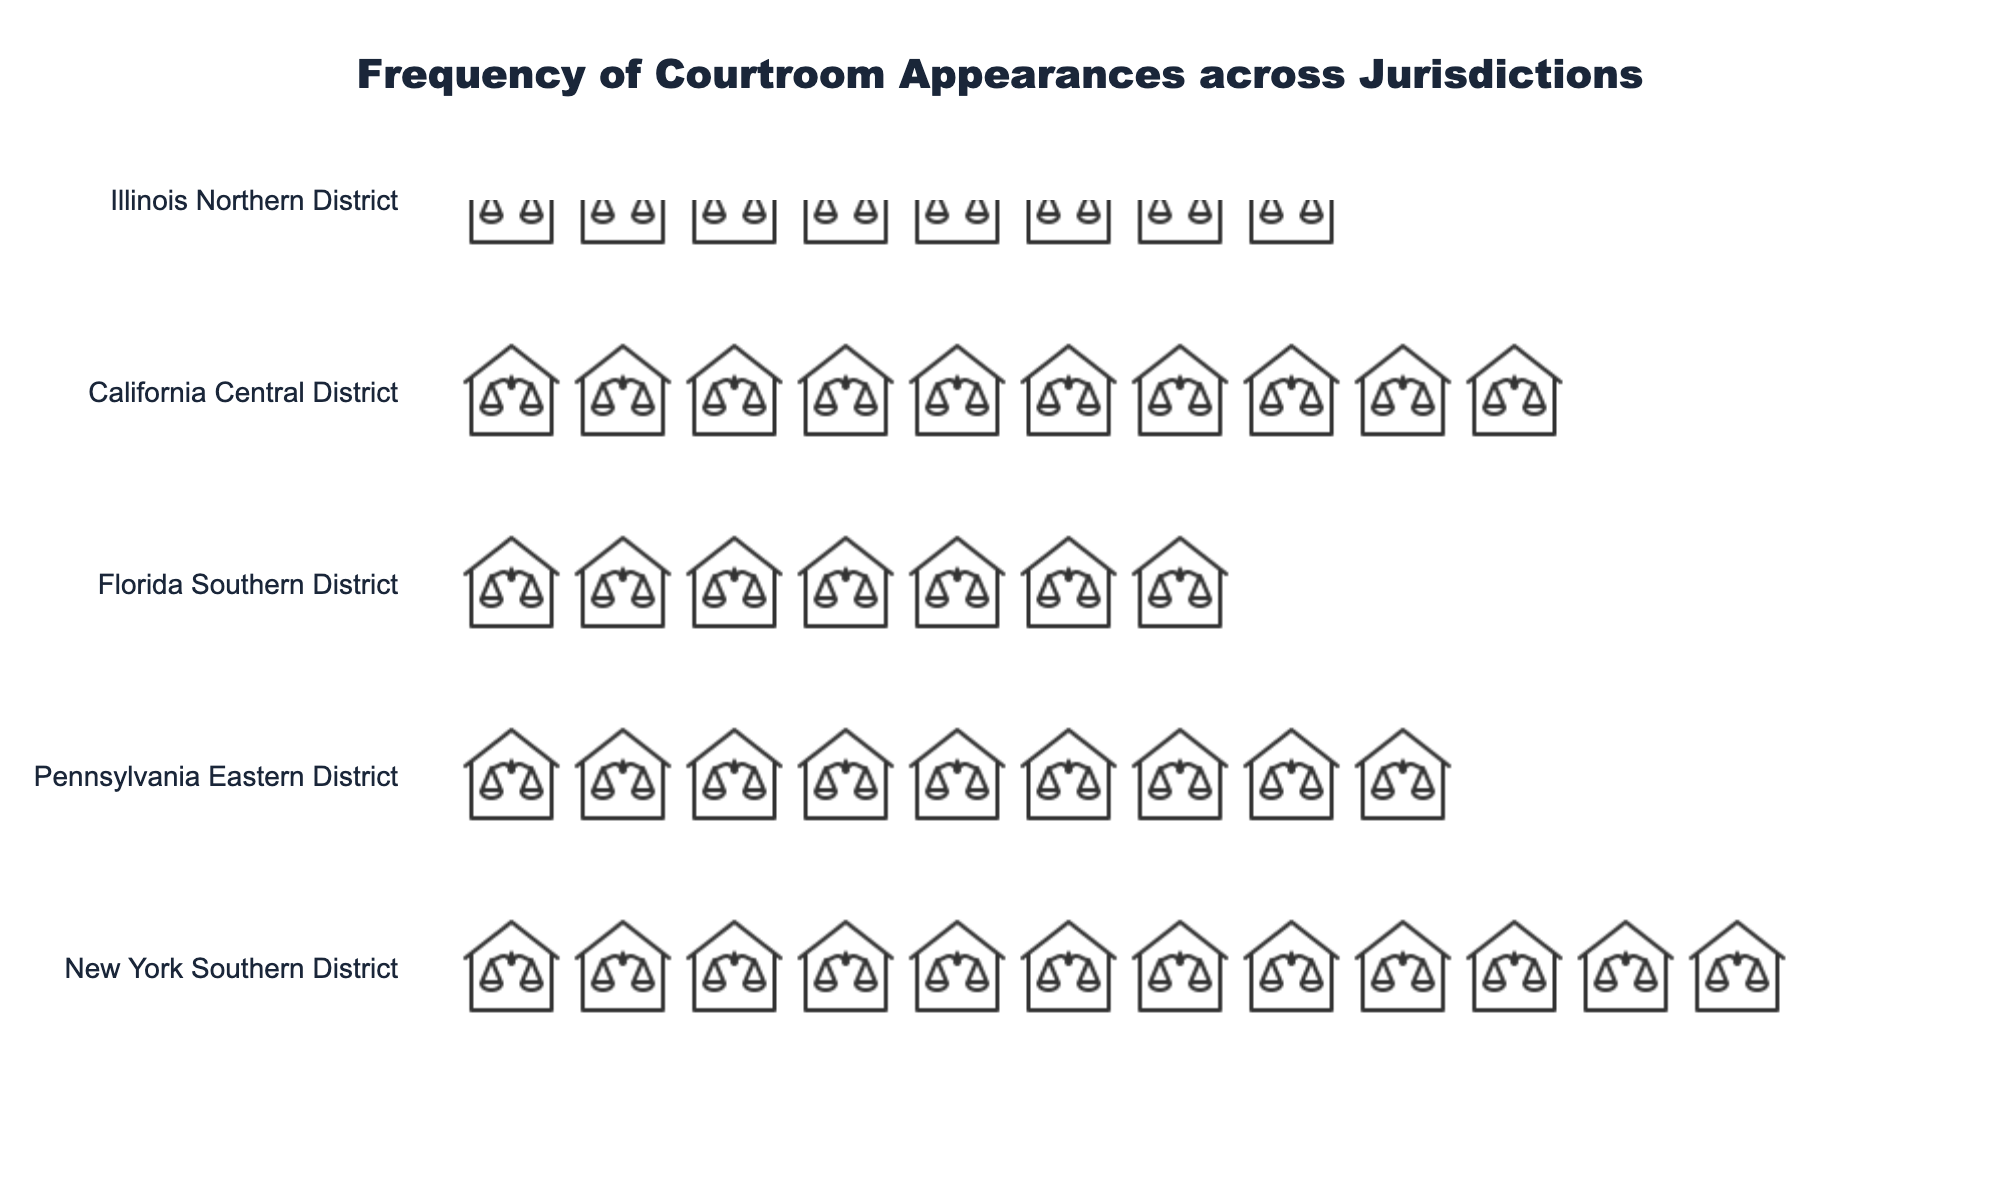What's the title of the plot? The title is prominently displayed at the top of the figure and helps convey the main subject of the plot.
Answer: Frequency of Courtroom Appearances across Jurisdictions Which jurisdiction has the highest number of courtroom appearances? The jurisdiction with the most courthouse icons will have the highest number of courtroom appearances.
Answer: New York Southern District What is the total number of courtroom appearances for California Central District and Texas Eastern District combined? Identify the number of appearances for each jurisdiction and sum them up: California Central District has 9 and Texas Eastern District has 7, so 9 + 7 = 16.
Answer: 16 Which jurisdictions have more than eight courtroom appearances? Compare the number of courthouse icons for each jurisdiction and list those with more than eight.
Answer: New York Southern District, Florida Southern District, Pennsylvania Eastern District How many jurisdictions have exactly six courtroom appearances? Count the number of jurisdictions with exactly six courthouse icons next to their name.
Answer: 1 Which jurisdiction has the smallest number of courtroom appearances? The jurisdiction with the fewest courthouse icons will have the smallest number of appearances.
Answer: Washington Western District What is the difference in courtroom appearances between Florida Southern District and Illinois Northern District? Subtract the number of appearances for Illinois Northern District from Florida Southern District: 10 - 8 = 2.
Answer: 2 How many courthouse icons will you find next to Massachusetts District? Count the number of courthouse icons next to Massachusetts District.
Answer: 6 Are there more courtroom appearances in Pennsylvania Eastern District or California Central District? Compare the number of courthouse icons for Pennsylvania Eastern District and California Central District, with Pennsylvania Eastern District having 11 and California Central District having 9.
Answer: Pennsylvania Eastern District What is the average number of courtroom appearances across all jurisdictions? Add the total number of courtroom appearances and divide by the number of jurisdictions: (12 + 9 + 7 + 10 + 8 + 6 + 5 + 11) / 8 = 68 / 8 = 8.5.
Answer: 8.5 